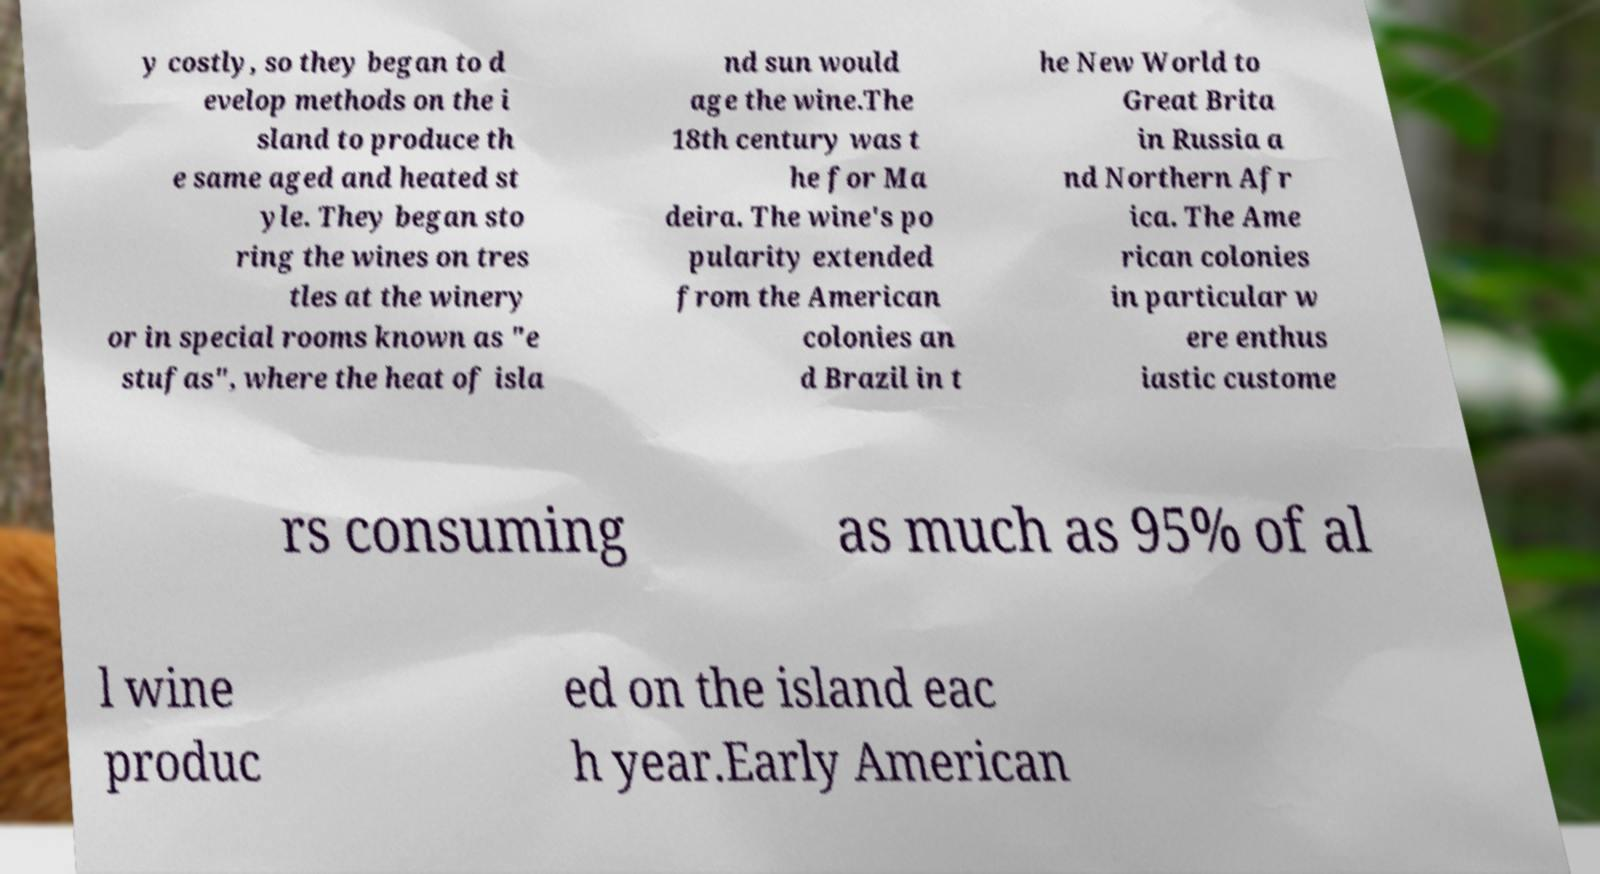Can you read and provide the text displayed in the image?This photo seems to have some interesting text. Can you extract and type it out for me? y costly, so they began to d evelop methods on the i sland to produce th e same aged and heated st yle. They began sto ring the wines on tres tles at the winery or in special rooms known as "e stufas", where the heat of isla nd sun would age the wine.The 18th century was t he for Ma deira. The wine's po pularity extended from the American colonies an d Brazil in t he New World to Great Brita in Russia a nd Northern Afr ica. The Ame rican colonies in particular w ere enthus iastic custome rs consuming as much as 95% of al l wine produc ed on the island eac h year.Early American 